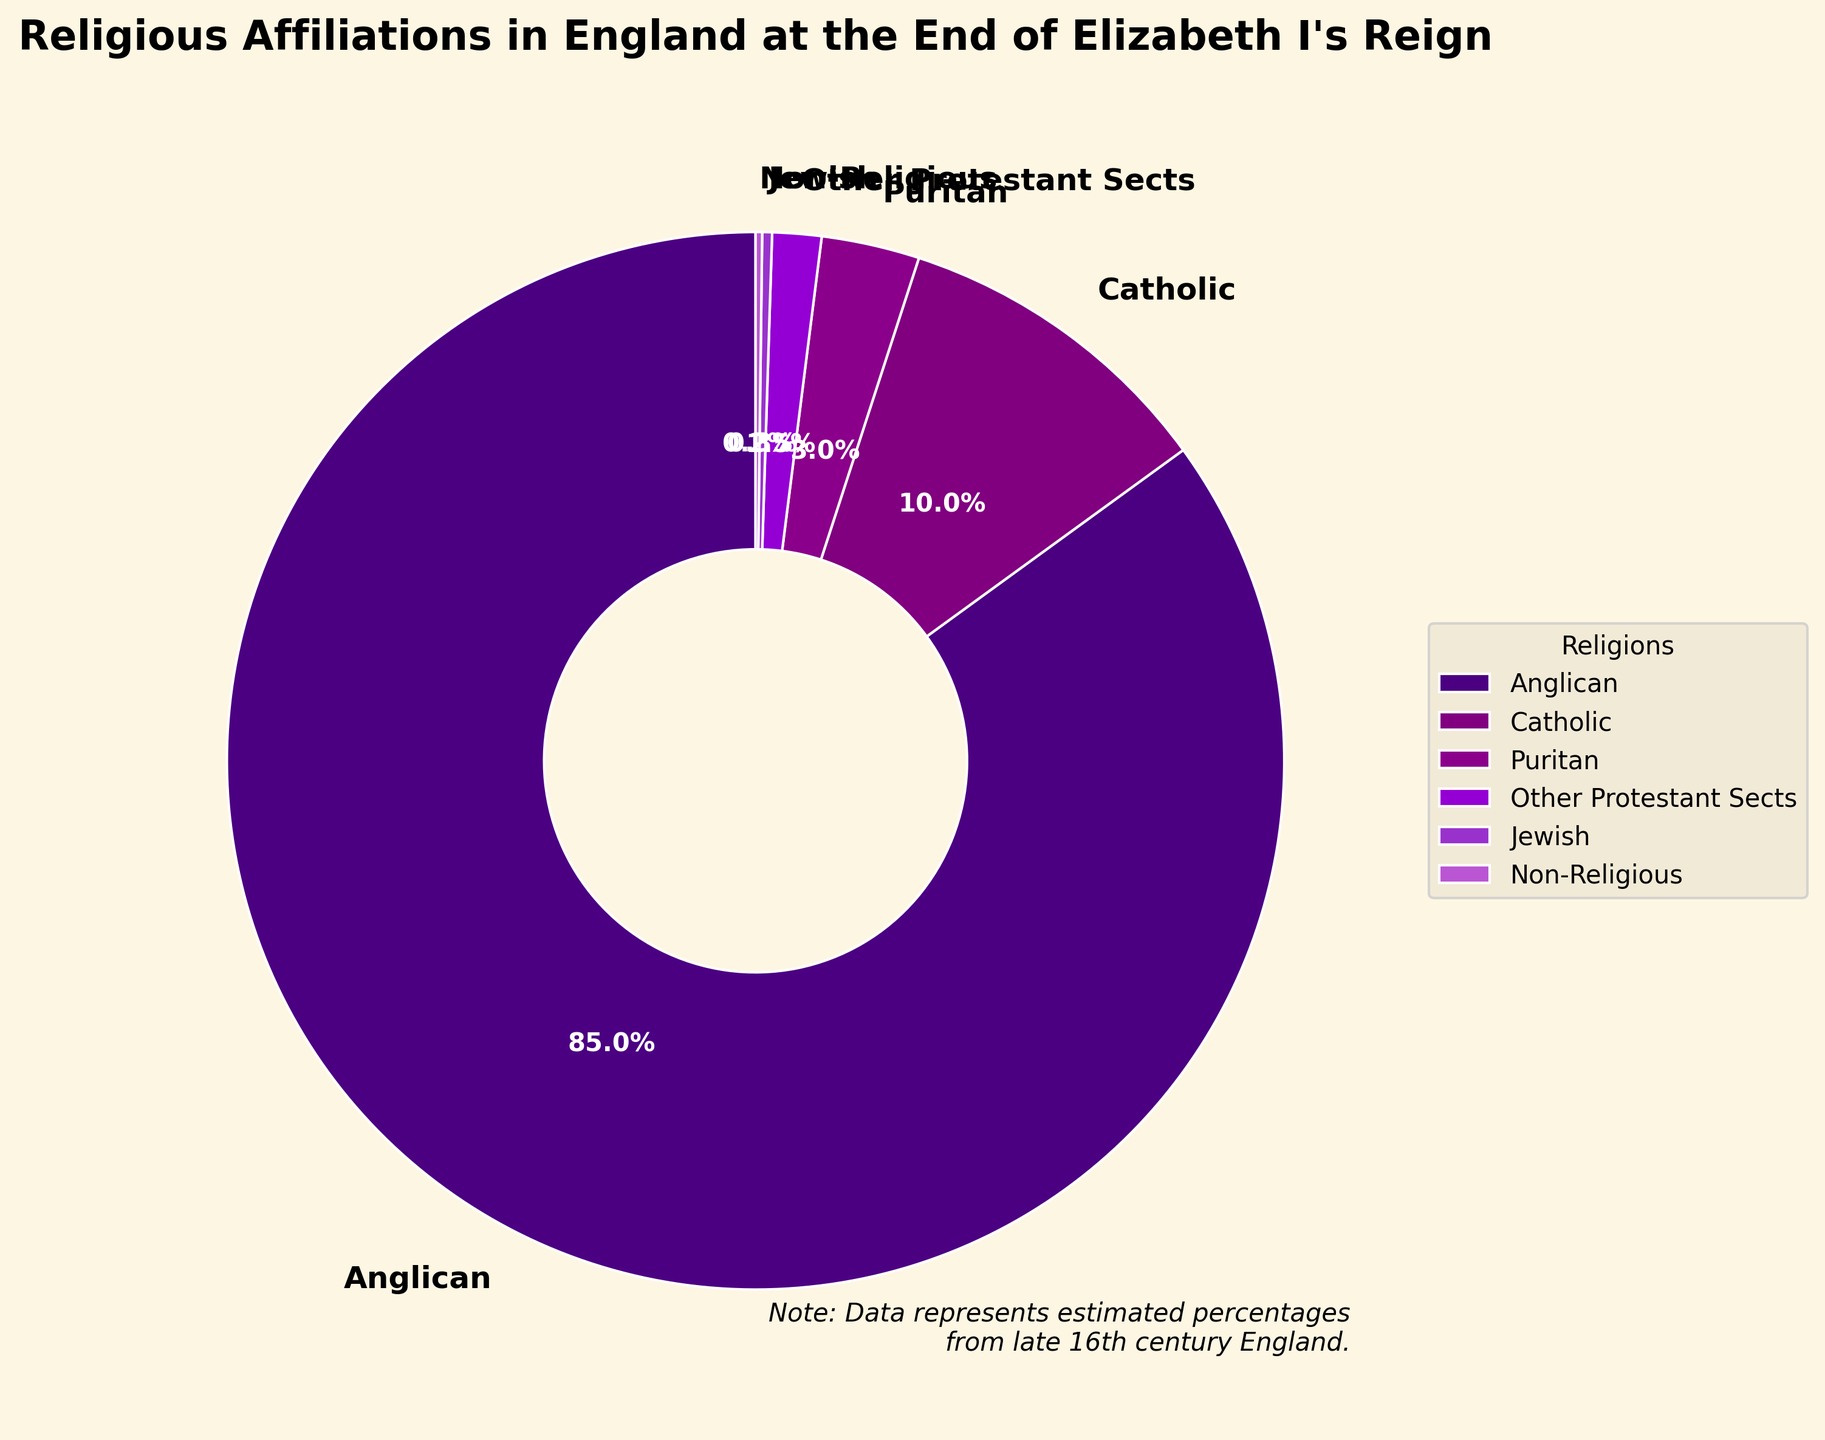What's the percentage of people who were either Anglican or Catholic? Add the percentages of Anglican and Catholic: 85% + 10% = 95%
Answer: 95% How does the percentage of Puritans compare to the percentage of Non-Religious people? The percentage of Puritans is 3%, and the percentage of Non-Religious people is 0.2%. Since 3% is greater than 0.2%, there are more Puritans than Non-Religious people.
Answer: Puritans have a higher percentage Which religion had the second highest affiliation after Anglican? The religion with the second highest affiliation is Catholic with 10%.
Answer: Catholic What is the total percentage of all Protestant sects combined (Anglican, Puritan, Other Protestant Sects)? Add the percentages of all Protestant sects: 85% (Anglican) + 3% (Puritan) + 1.5% (Other Protestant Sects) = 89.5%
Answer: 89.5% Describe the color representing the Jewish affiliation in the chart. The Jewish affiliation is represented by the lightest color on the chart.
Answer: Light purple Is the percentage of people belonging to Other Protestant Sects greater than that of Jewish and Non-Religious individuals combined? Add the percentages of Jewish and Non-Religious individuals: 0.3% + 0.2% = 0.5%. The percentage for Other Protestant Sects is 1.5%, which is greater than 0.5%.
Answer: Yes What is the difference in percentage between Catholics and Puritans? Subtract the percentage of Puritans from Catholics: 10% - 3% = 7%
Answer: 7% Which group has the smallest representation, and what percentage do they hold? The group with the smallest representation is Non-Religious, holding 0.2% of the total.
Answer: Non-Religious, 0.2% 